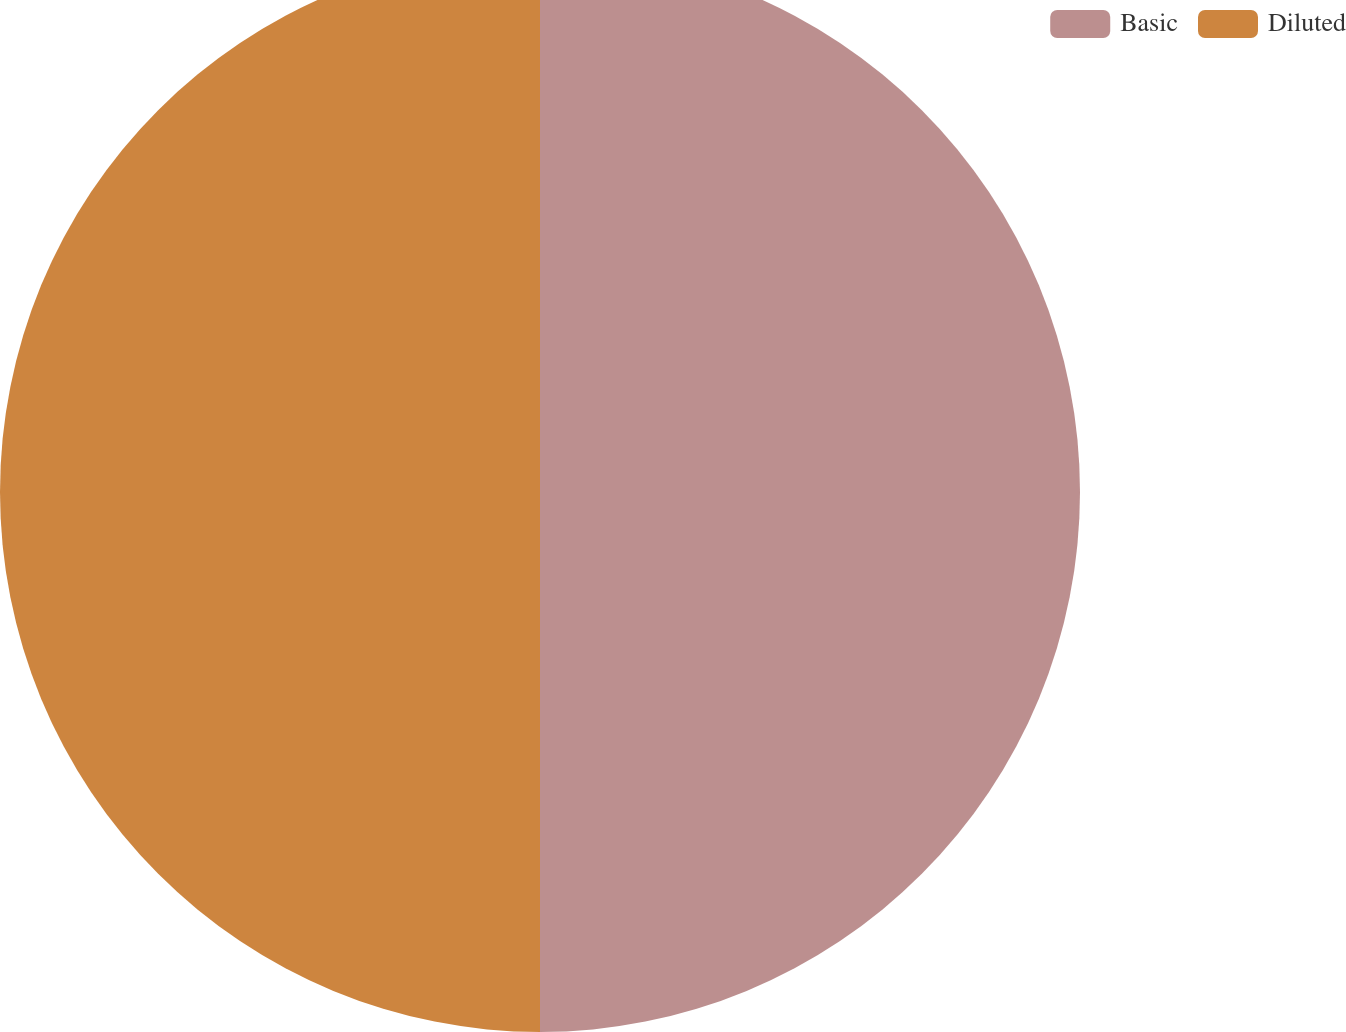Convert chart to OTSL. <chart><loc_0><loc_0><loc_500><loc_500><pie_chart><fcel>Basic<fcel>Diluted<nl><fcel>50.0%<fcel>50.0%<nl></chart> 